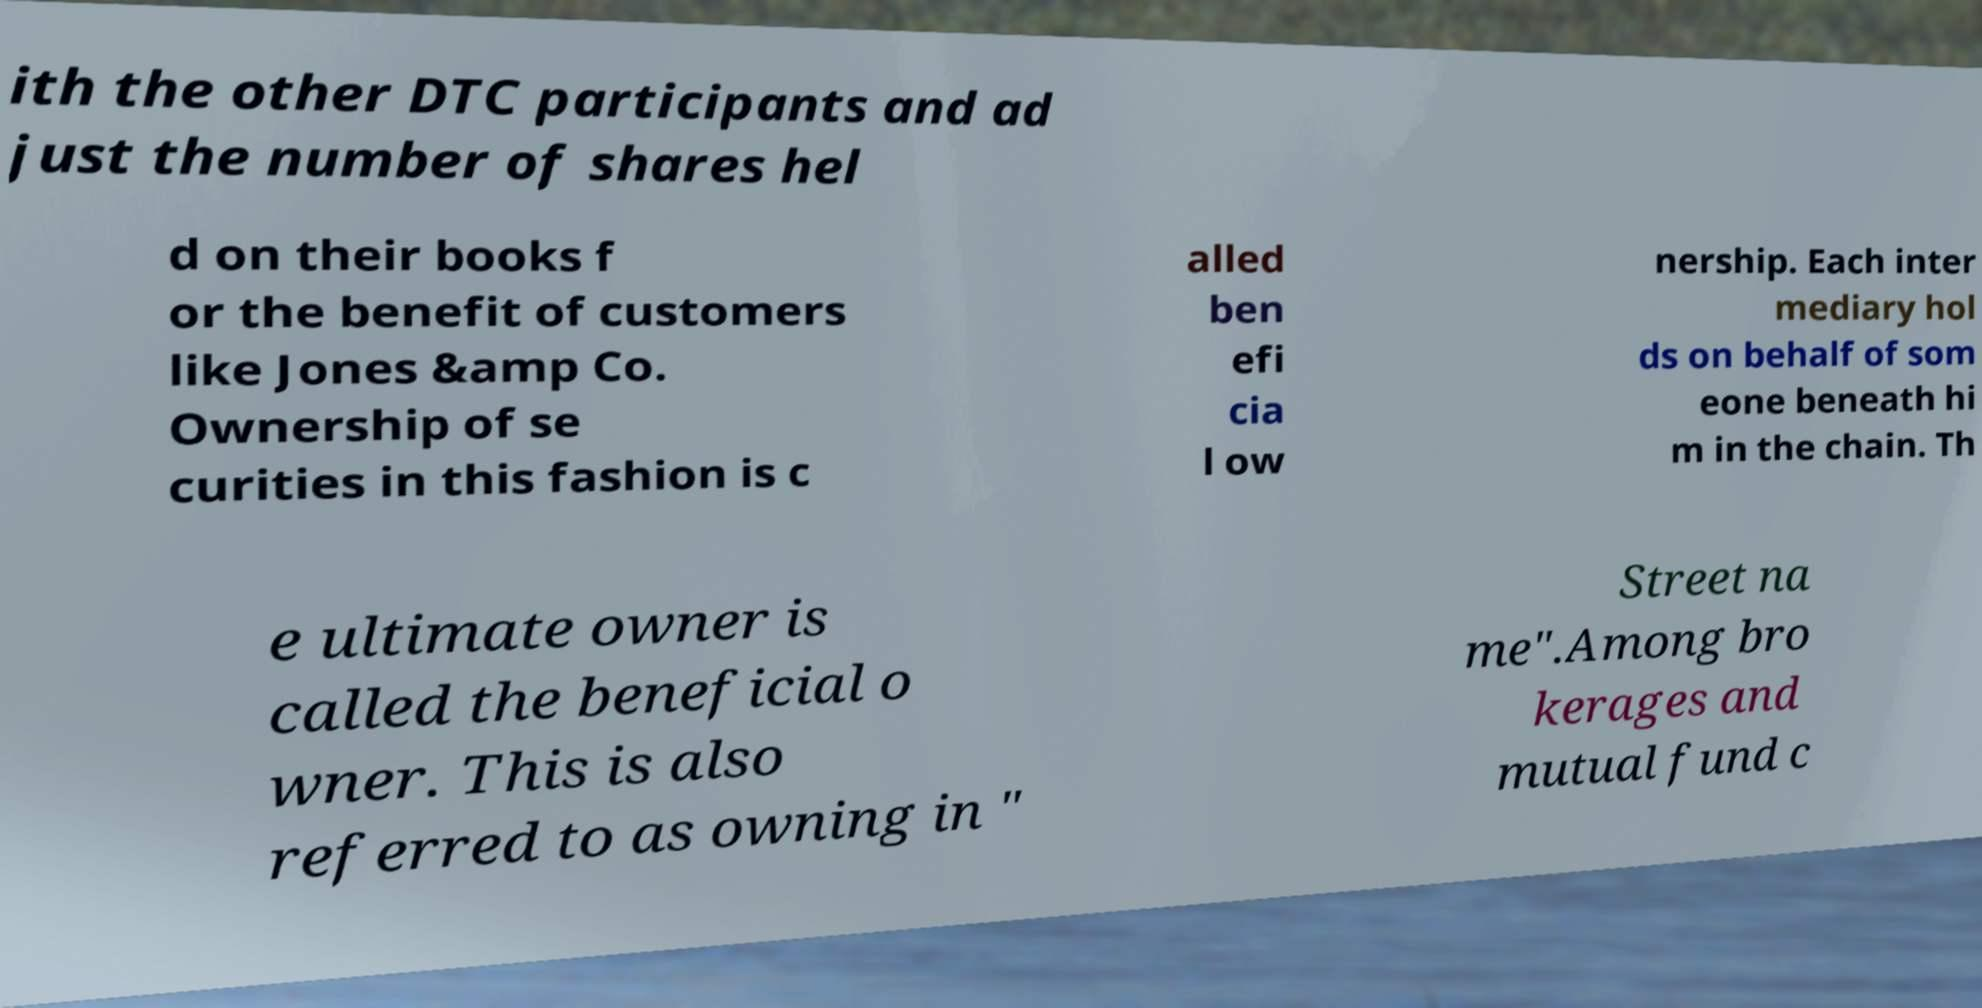I need the written content from this picture converted into text. Can you do that? ith the other DTC participants and ad just the number of shares hel d on their books f or the benefit of customers like Jones &amp Co. Ownership of se curities in this fashion is c alled ben efi cia l ow nership. Each inter mediary hol ds on behalf of som eone beneath hi m in the chain. Th e ultimate owner is called the beneficial o wner. This is also referred to as owning in " Street na me".Among bro kerages and mutual fund c 